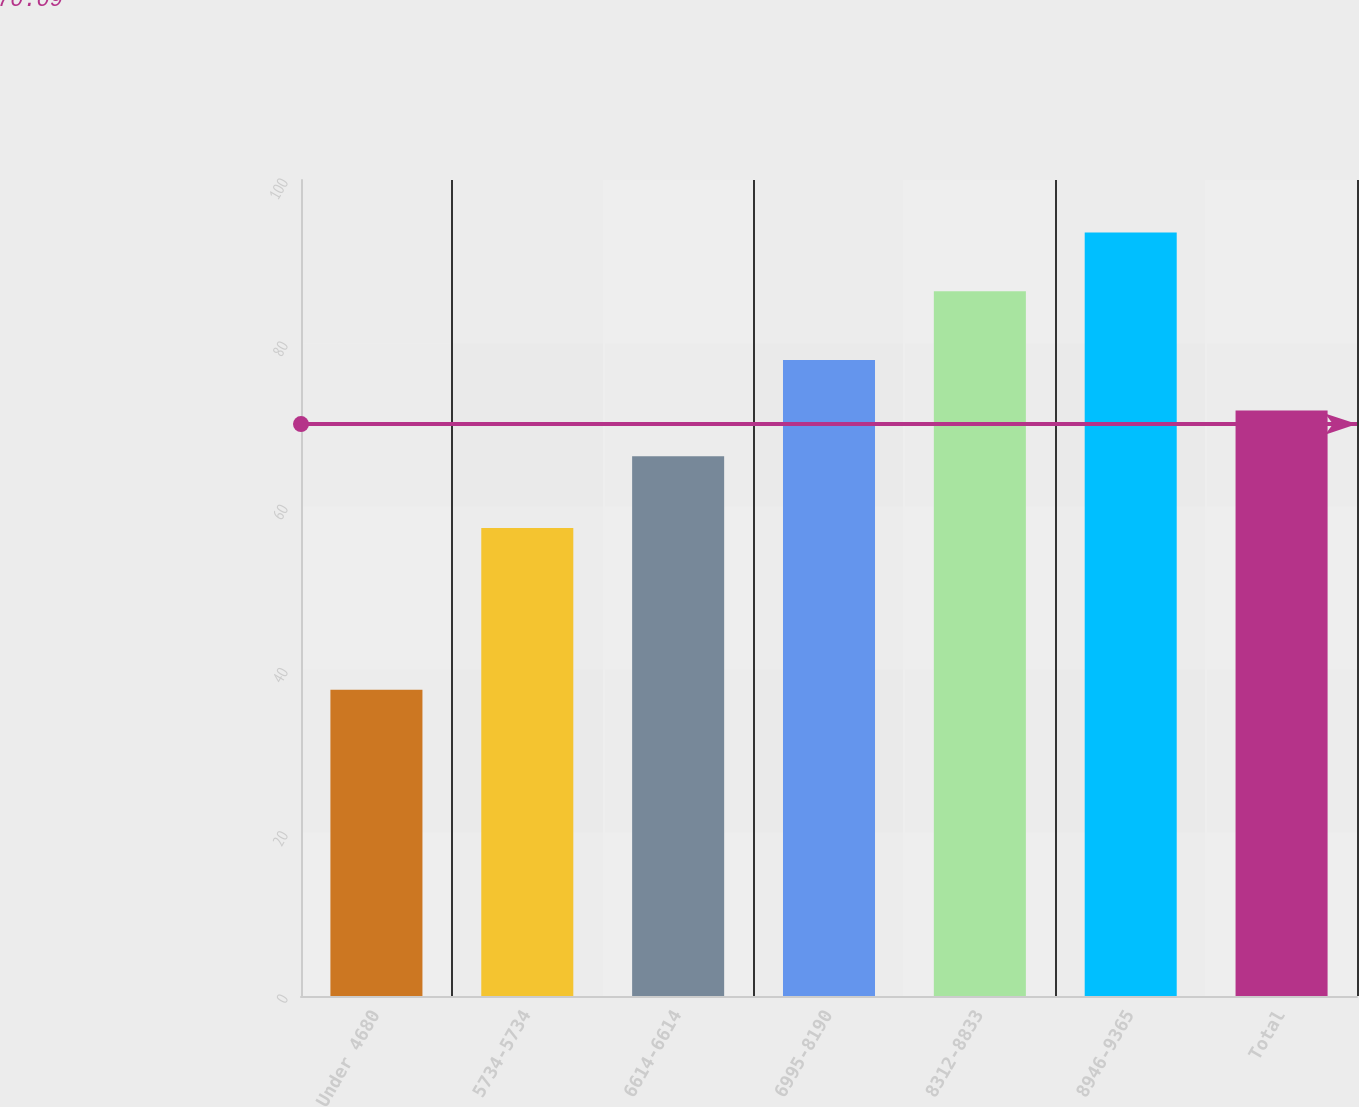Convert chart to OTSL. <chart><loc_0><loc_0><loc_500><loc_500><bar_chart><fcel>Under 4680<fcel>5734-5734<fcel>6614-6614<fcel>6995-8190<fcel>8312-8833<fcel>8946-9365<fcel>Total<nl><fcel>37.53<fcel>57.34<fcel>66.14<fcel>77.94<fcel>86.38<fcel>93.57<fcel>71.74<nl></chart> 